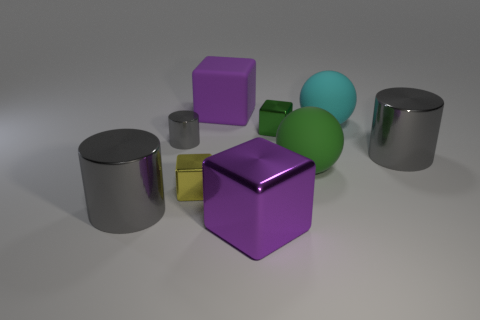Is the tiny gray thing the same shape as the large green object?
Provide a succinct answer. No. There is a gray cylinder on the right side of the purple object in front of the cylinder that is right of the purple rubber cube; what size is it?
Your response must be concise. Large. What number of other objects are the same material as the green block?
Your answer should be compact. 5. There is a large cylinder on the left side of the big matte block; what color is it?
Offer a terse response. Gray. The big gray object on the right side of the big purple block that is on the right side of the purple thing behind the large metal cube is made of what material?
Keep it short and to the point. Metal. Are there any large purple matte things that have the same shape as the tiny gray thing?
Make the answer very short. No. What shape is the gray thing that is the same size as the green shiny thing?
Your response must be concise. Cylinder. What number of objects are both left of the big cyan object and behind the green metallic object?
Keep it short and to the point. 1. Are there fewer cubes that are behind the small yellow thing than large red cylinders?
Ensure brevity in your answer.  No. Are there any cyan objects that have the same size as the purple matte block?
Make the answer very short. Yes. 